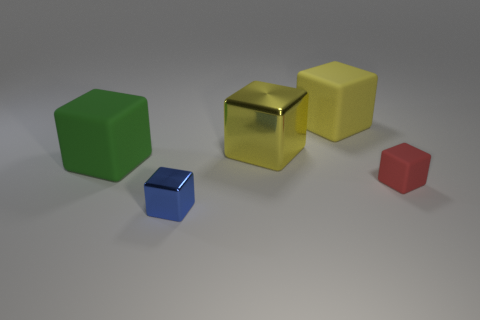There is a big rubber object to the left of the big yellow rubber object; does it have the same shape as the rubber thing in front of the green matte block?
Your response must be concise. Yes. What is the material of the cube that is on the left side of the blue metallic block?
Offer a very short reply. Rubber. What is the size of the rubber cube that is the same color as the large metal cube?
Give a very brief answer. Large. What number of objects are shiny blocks in front of the small matte thing or large blue metallic balls?
Offer a terse response. 1. Are there an equal number of big cubes that are to the right of the red rubber block and big rubber cubes?
Keep it short and to the point. No. Do the green matte cube and the red rubber block have the same size?
Give a very brief answer. No. What color is the metal cube that is the same size as the yellow matte object?
Provide a succinct answer. Yellow. There is a red object; is it the same size as the matte object that is to the left of the big yellow rubber thing?
Provide a short and direct response. No. What number of small rubber things have the same color as the big shiny cube?
Your answer should be compact. 0. What number of objects are brown matte spheres or yellow things that are behind the large yellow metal block?
Make the answer very short. 1. 